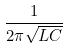<formula> <loc_0><loc_0><loc_500><loc_500>\frac { 1 } { 2 \pi \sqrt { L C } }</formula> 